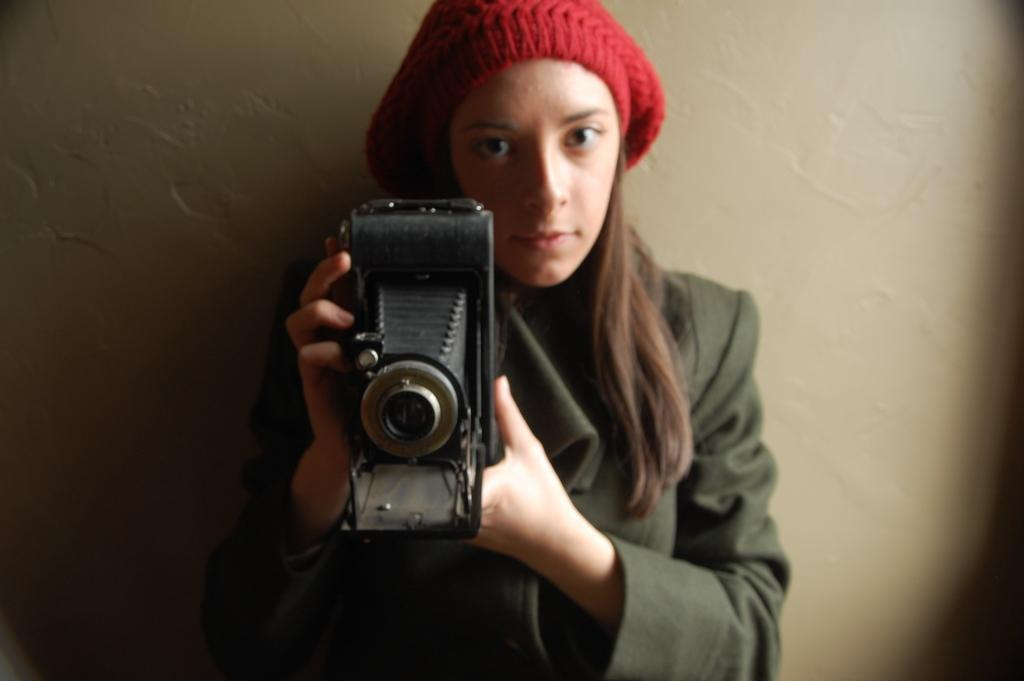What is the main subject of the image? There is a person in the image. What is the person holding in the image? The person is holding a camera. What can be seen in the background of the image? There is a wall in the background of the image. What type of ice can be seen melting on the hydrant in the image? There is no ice or hydrant present in the image. How does the person stretch their arms in the image? The person does not stretch their arms in the image; they are holding a camera. 